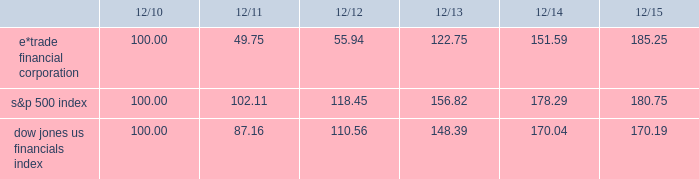Table of contents performance graph the following performance graph shows the cumulative total return to a holder of the company 2019s common stock , assuming dividend reinvestment , compared with the cumulative total return , assuming dividend reinvestment , of the standard & poor ( "s&p" ) 500 index and the dow jones us financials index during the period from december 31 , 2010 through december 31 , 2015. .

What was the difference in percentage cumulative total return for e*trade financial corporation and the s&p 500 index for the five years ended 12/15? 
Computations: (((185.25 - 100) / 100) - ((180.75 - 100) / 100))
Answer: 0.045. 